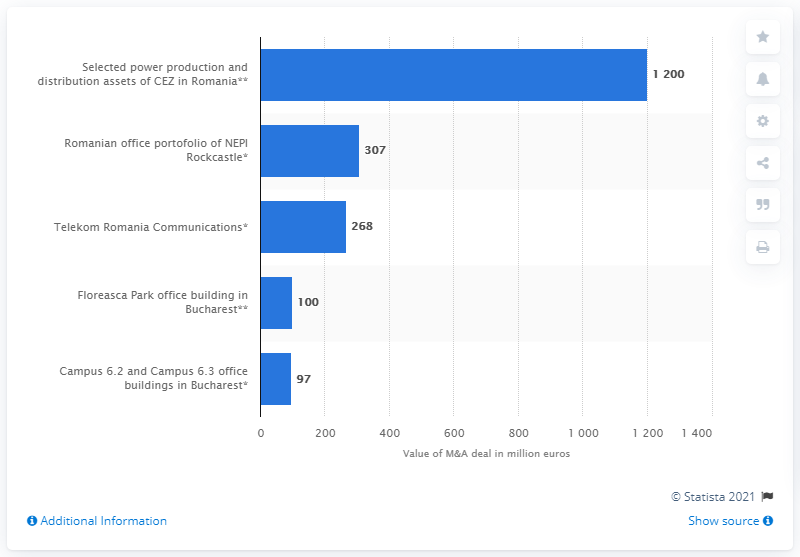Highlight a few significant elements in this photo. The largest deal in Romania in 2020 was valued at 1200. The smallest deal in the top five in Romania in 2020 was worth 97. 